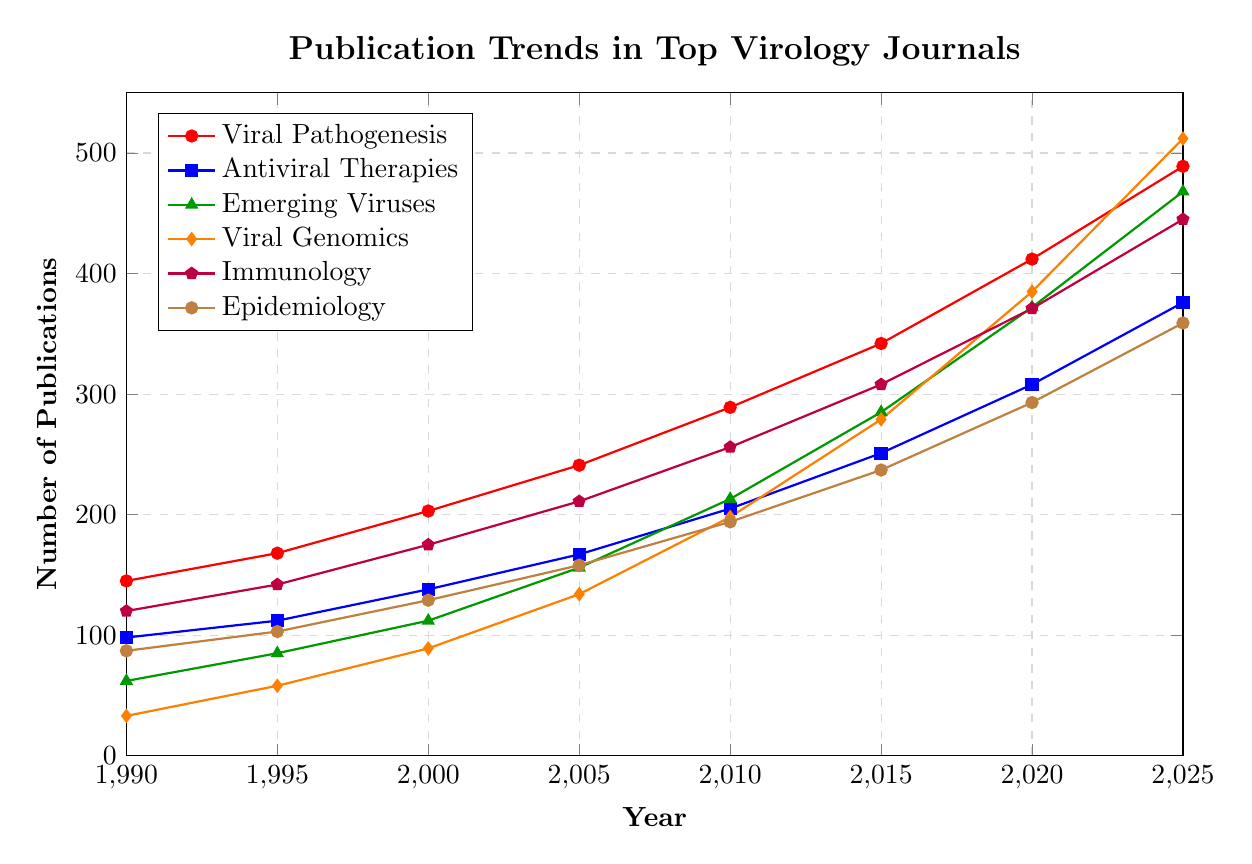How has the number of publications in "Viral Genomics" changed from 1990 to 2025? In 1990, the number of publications in "Viral Genomics" was 33. By 2025, it increased to 512. The change is computed by subtracting the initial value from the final value: 512 - 33 = 479.
Answer: 479 Which research focus area saw the highest number of publications in 2020? By examining the values for the year 2020, "Viral Genomics" has the highest number with 385 publications.
Answer: Viral Genomics What is the total number of publications across all research focus areas in 2015? Add the publication numbers for all focus areas in 2015: 342 (Viral Pathogenesis) + 251 (Antiviral Therapies) + 285 (Emerging Viruses) + 279 (Viral Genomics) + 308 (Immunology) + 237 (Epidemiology) = 1702.
Answer: 1702 Between 1995 and 2000, which research focus area experienced the greatest increase in the number of publications? Calculate the differences between 2000 and 1995 for each research focus area and identify the greatest one: Viral Pathogenesis (203-168=35), Antiviral Therapies (138-112=26), Emerging Viruses (112-85=27), Viral Genomics (89-58=31), Immunology (175-142=33), Epidemiology (129-103=26). "Viral Pathogenesis" had the highest increase of 35.
Answer: Viral Pathogenesis Compare the number of publications in "Immunology" and "Epidemiology" in 2025. Which has more? The number of publications in 2025 for "Immunology" is 445 and for "Epidemiology" is 359. "Immunology" has more publications.
Answer: Immunology How did the number of publications for "Emerging Viruses" change between 2005 and 2010? In 2005, there were 156 publications for "Emerging Viruses." This increased to 213 in 2010. The change is computed by subtracting the 2005 value from the 2010 value: 213 - 156 = 57.
Answer: 57 Which two research focus areas had the closest number of publications in 1995? Compare the numbers in 1995 for all focus areas: Viral Pathogenesis (168), Antiviral Therapies (112), Emerging Viruses (85), Viral Genomics (58), Immunology (142), Epidemiology (103). The closest values are for Antiviral Therapies (112) and Epidemiology (103) with a difference of 9.
Answer: Antiviral Therapies and Epidemiology What's the average number of publications for "Antiviral Therapies" between 1990 and 2025? Add the publication numbers for "Antiviral Therapies" across the years and divide by the number of data points: (98+112+138+167+205+251+308+376)/8 = 207.125.
Answer: 207.125 What is the trend of publications in "Antiviral Therapies" from 1990 to 2025? By observing the data, the number of publications in "Antiviral Therapies" increases every recorded year from 98 in 1990 to 376 in 2025, indicating a consistent upward trend.
Answer: Upward trend Between which consecutive years did "Viral Pathogenesis" see the greatest increase in publications? Calculate the increases between consecutive years for "Viral Pathogenesis": 1995-1990 (168-145=23), 2000-1995 (203-168=35), 2005-2000 (241-203=38), 2010-2005 (289-241=48), 2015-2010 (342-289=53), 2020-2015 (412-342=70), 2025-2020 (489-412=77). The greatest increase happened between 2020 and 2025 with a jump of 77.
Answer: 2020 and 2025 